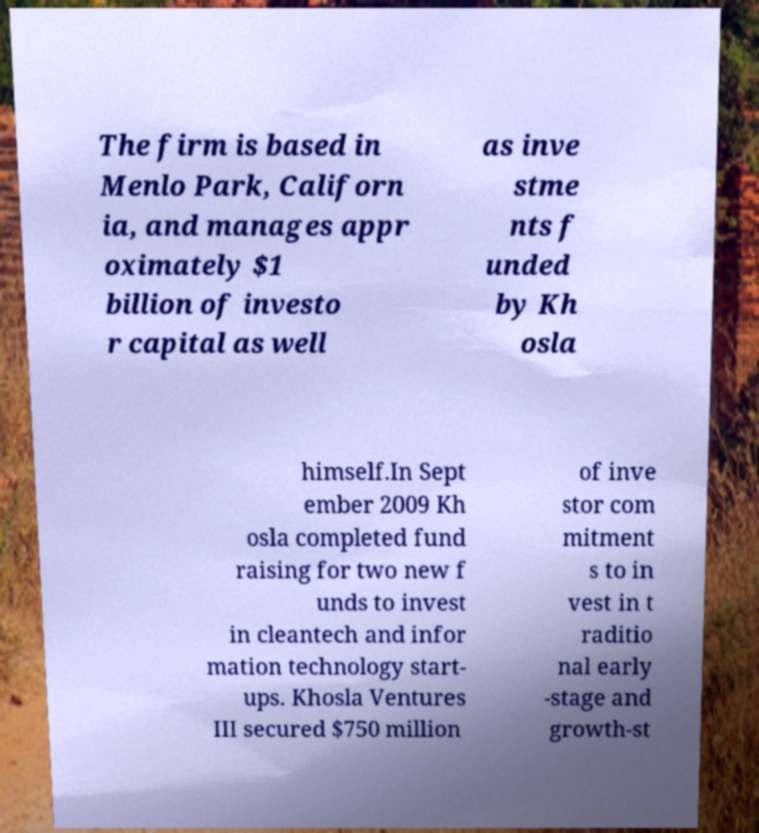There's text embedded in this image that I need extracted. Can you transcribe it verbatim? The firm is based in Menlo Park, Californ ia, and manages appr oximately $1 billion of investo r capital as well as inve stme nts f unded by Kh osla himself.In Sept ember 2009 Kh osla completed fund raising for two new f unds to invest in cleantech and infor mation technology start- ups. Khosla Ventures III secured $750 million of inve stor com mitment s to in vest in t raditio nal early -stage and growth-st 